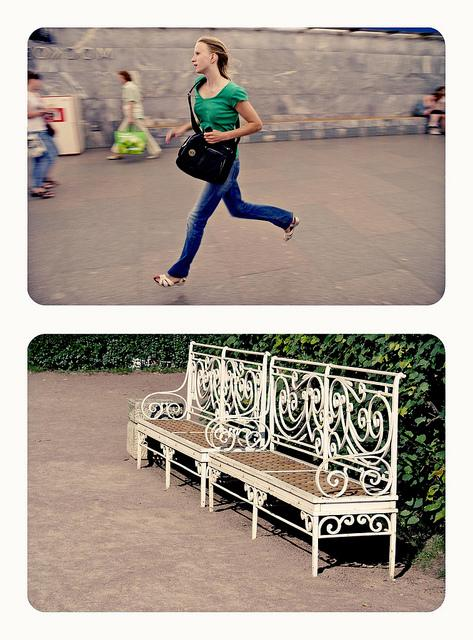Which country invented free public benches? Please explain your reasoning. france. France has public benches available in parks. 